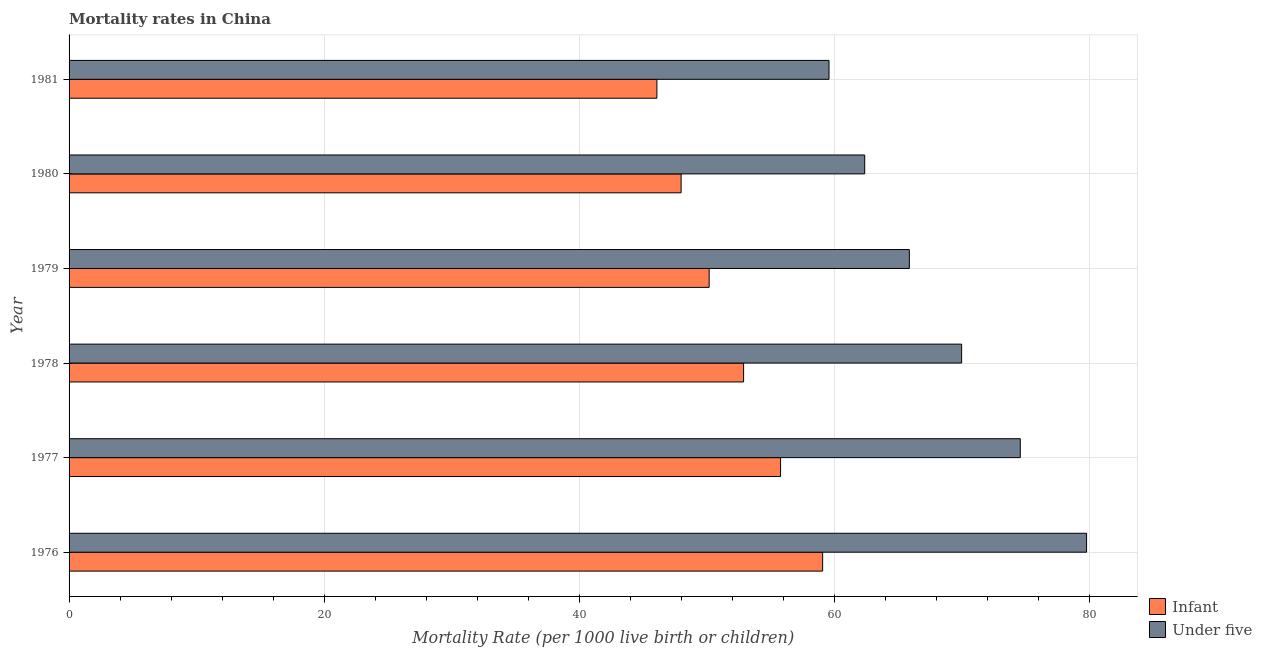Are the number of bars on each tick of the Y-axis equal?
Ensure brevity in your answer.  Yes. How many bars are there on the 4th tick from the top?
Offer a very short reply. 2. How many bars are there on the 3rd tick from the bottom?
Your answer should be very brief. 2. What is the label of the 4th group of bars from the top?
Your response must be concise. 1978. What is the under-5 mortality rate in 1979?
Offer a very short reply. 65.9. Across all years, what is the maximum infant mortality rate?
Offer a very short reply. 59.1. Across all years, what is the minimum under-5 mortality rate?
Give a very brief answer. 59.6. In which year was the infant mortality rate maximum?
Your response must be concise. 1976. What is the total infant mortality rate in the graph?
Your answer should be very brief. 312.1. What is the difference between the infant mortality rate in 1979 and that in 1980?
Make the answer very short. 2.2. What is the average under-5 mortality rate per year?
Ensure brevity in your answer.  68.72. In the year 1979, what is the difference between the infant mortality rate and under-5 mortality rate?
Your response must be concise. -15.7. What is the ratio of the under-5 mortality rate in 1980 to that in 1981?
Provide a succinct answer. 1.05. Is the difference between the under-5 mortality rate in 1979 and 1981 greater than the difference between the infant mortality rate in 1979 and 1981?
Ensure brevity in your answer.  Yes. What is the difference between the highest and the lowest under-5 mortality rate?
Provide a succinct answer. 20.2. In how many years, is the under-5 mortality rate greater than the average under-5 mortality rate taken over all years?
Provide a short and direct response. 3. Is the sum of the infant mortality rate in 1980 and 1981 greater than the maximum under-5 mortality rate across all years?
Offer a very short reply. Yes. What does the 2nd bar from the top in 1978 represents?
Ensure brevity in your answer.  Infant. What does the 1st bar from the bottom in 1981 represents?
Your response must be concise. Infant. Are all the bars in the graph horizontal?
Your response must be concise. Yes. Are the values on the major ticks of X-axis written in scientific E-notation?
Offer a very short reply. No. How many legend labels are there?
Give a very brief answer. 2. How are the legend labels stacked?
Ensure brevity in your answer.  Vertical. What is the title of the graph?
Your answer should be compact. Mortality rates in China. Does "RDB nonconcessional" appear as one of the legend labels in the graph?
Provide a succinct answer. No. What is the label or title of the X-axis?
Keep it short and to the point. Mortality Rate (per 1000 live birth or children). What is the label or title of the Y-axis?
Provide a short and direct response. Year. What is the Mortality Rate (per 1000 live birth or children) in Infant in 1976?
Provide a succinct answer. 59.1. What is the Mortality Rate (per 1000 live birth or children) in Under five in 1976?
Your response must be concise. 79.8. What is the Mortality Rate (per 1000 live birth or children) in Infant in 1977?
Your response must be concise. 55.8. What is the Mortality Rate (per 1000 live birth or children) of Under five in 1977?
Keep it short and to the point. 74.6. What is the Mortality Rate (per 1000 live birth or children) in Infant in 1978?
Give a very brief answer. 52.9. What is the Mortality Rate (per 1000 live birth or children) of Infant in 1979?
Your answer should be compact. 50.2. What is the Mortality Rate (per 1000 live birth or children) of Under five in 1979?
Ensure brevity in your answer.  65.9. What is the Mortality Rate (per 1000 live birth or children) of Infant in 1980?
Provide a short and direct response. 48. What is the Mortality Rate (per 1000 live birth or children) of Under five in 1980?
Your answer should be compact. 62.4. What is the Mortality Rate (per 1000 live birth or children) of Infant in 1981?
Give a very brief answer. 46.1. What is the Mortality Rate (per 1000 live birth or children) of Under five in 1981?
Your answer should be very brief. 59.6. Across all years, what is the maximum Mortality Rate (per 1000 live birth or children) in Infant?
Give a very brief answer. 59.1. Across all years, what is the maximum Mortality Rate (per 1000 live birth or children) in Under five?
Your response must be concise. 79.8. Across all years, what is the minimum Mortality Rate (per 1000 live birth or children) of Infant?
Offer a very short reply. 46.1. Across all years, what is the minimum Mortality Rate (per 1000 live birth or children) of Under five?
Provide a short and direct response. 59.6. What is the total Mortality Rate (per 1000 live birth or children) in Infant in the graph?
Give a very brief answer. 312.1. What is the total Mortality Rate (per 1000 live birth or children) in Under five in the graph?
Your answer should be very brief. 412.3. What is the difference between the Mortality Rate (per 1000 live birth or children) of Infant in 1976 and that in 1977?
Offer a very short reply. 3.3. What is the difference between the Mortality Rate (per 1000 live birth or children) of Infant in 1976 and that in 1978?
Provide a short and direct response. 6.2. What is the difference between the Mortality Rate (per 1000 live birth or children) of Under five in 1976 and that in 1978?
Ensure brevity in your answer.  9.8. What is the difference between the Mortality Rate (per 1000 live birth or children) of Infant in 1976 and that in 1979?
Offer a very short reply. 8.9. What is the difference between the Mortality Rate (per 1000 live birth or children) of Under five in 1976 and that in 1981?
Keep it short and to the point. 20.2. What is the difference between the Mortality Rate (per 1000 live birth or children) of Infant in 1977 and that in 1978?
Ensure brevity in your answer.  2.9. What is the difference between the Mortality Rate (per 1000 live birth or children) in Infant in 1977 and that in 1981?
Provide a succinct answer. 9.7. What is the difference between the Mortality Rate (per 1000 live birth or children) in Infant in 1978 and that in 1979?
Provide a succinct answer. 2.7. What is the difference between the Mortality Rate (per 1000 live birth or children) in Infant in 1978 and that in 1980?
Your answer should be compact. 4.9. What is the difference between the Mortality Rate (per 1000 live birth or children) in Infant in 1979 and that in 1981?
Give a very brief answer. 4.1. What is the difference between the Mortality Rate (per 1000 live birth or children) in Infant in 1976 and the Mortality Rate (per 1000 live birth or children) in Under five in 1977?
Keep it short and to the point. -15.5. What is the difference between the Mortality Rate (per 1000 live birth or children) of Infant in 1976 and the Mortality Rate (per 1000 live birth or children) of Under five in 1978?
Keep it short and to the point. -10.9. What is the difference between the Mortality Rate (per 1000 live birth or children) of Infant in 1976 and the Mortality Rate (per 1000 live birth or children) of Under five in 1979?
Ensure brevity in your answer.  -6.8. What is the difference between the Mortality Rate (per 1000 live birth or children) in Infant in 1976 and the Mortality Rate (per 1000 live birth or children) in Under five in 1981?
Keep it short and to the point. -0.5. What is the difference between the Mortality Rate (per 1000 live birth or children) of Infant in 1977 and the Mortality Rate (per 1000 live birth or children) of Under five in 1978?
Ensure brevity in your answer.  -14.2. What is the difference between the Mortality Rate (per 1000 live birth or children) in Infant in 1978 and the Mortality Rate (per 1000 live birth or children) in Under five in 1979?
Keep it short and to the point. -13. What is the difference between the Mortality Rate (per 1000 live birth or children) in Infant in 1978 and the Mortality Rate (per 1000 live birth or children) in Under five in 1980?
Your response must be concise. -9.5. What is the difference between the Mortality Rate (per 1000 live birth or children) in Infant in 1979 and the Mortality Rate (per 1000 live birth or children) in Under five in 1981?
Your response must be concise. -9.4. What is the difference between the Mortality Rate (per 1000 live birth or children) in Infant in 1980 and the Mortality Rate (per 1000 live birth or children) in Under five in 1981?
Keep it short and to the point. -11.6. What is the average Mortality Rate (per 1000 live birth or children) in Infant per year?
Make the answer very short. 52.02. What is the average Mortality Rate (per 1000 live birth or children) of Under five per year?
Keep it short and to the point. 68.72. In the year 1976, what is the difference between the Mortality Rate (per 1000 live birth or children) in Infant and Mortality Rate (per 1000 live birth or children) in Under five?
Your answer should be very brief. -20.7. In the year 1977, what is the difference between the Mortality Rate (per 1000 live birth or children) in Infant and Mortality Rate (per 1000 live birth or children) in Under five?
Your answer should be compact. -18.8. In the year 1978, what is the difference between the Mortality Rate (per 1000 live birth or children) in Infant and Mortality Rate (per 1000 live birth or children) in Under five?
Your response must be concise. -17.1. In the year 1979, what is the difference between the Mortality Rate (per 1000 live birth or children) of Infant and Mortality Rate (per 1000 live birth or children) of Under five?
Your answer should be compact. -15.7. In the year 1980, what is the difference between the Mortality Rate (per 1000 live birth or children) in Infant and Mortality Rate (per 1000 live birth or children) in Under five?
Your answer should be very brief. -14.4. In the year 1981, what is the difference between the Mortality Rate (per 1000 live birth or children) of Infant and Mortality Rate (per 1000 live birth or children) of Under five?
Give a very brief answer. -13.5. What is the ratio of the Mortality Rate (per 1000 live birth or children) in Infant in 1976 to that in 1977?
Give a very brief answer. 1.06. What is the ratio of the Mortality Rate (per 1000 live birth or children) of Under five in 1976 to that in 1977?
Give a very brief answer. 1.07. What is the ratio of the Mortality Rate (per 1000 live birth or children) in Infant in 1976 to that in 1978?
Your response must be concise. 1.12. What is the ratio of the Mortality Rate (per 1000 live birth or children) of Under five in 1976 to that in 1978?
Offer a very short reply. 1.14. What is the ratio of the Mortality Rate (per 1000 live birth or children) of Infant in 1976 to that in 1979?
Offer a terse response. 1.18. What is the ratio of the Mortality Rate (per 1000 live birth or children) in Under five in 1976 to that in 1979?
Offer a terse response. 1.21. What is the ratio of the Mortality Rate (per 1000 live birth or children) in Infant in 1976 to that in 1980?
Your response must be concise. 1.23. What is the ratio of the Mortality Rate (per 1000 live birth or children) of Under five in 1976 to that in 1980?
Your answer should be compact. 1.28. What is the ratio of the Mortality Rate (per 1000 live birth or children) of Infant in 1976 to that in 1981?
Your answer should be very brief. 1.28. What is the ratio of the Mortality Rate (per 1000 live birth or children) in Under five in 1976 to that in 1981?
Give a very brief answer. 1.34. What is the ratio of the Mortality Rate (per 1000 live birth or children) in Infant in 1977 to that in 1978?
Make the answer very short. 1.05. What is the ratio of the Mortality Rate (per 1000 live birth or children) of Under five in 1977 to that in 1978?
Your answer should be very brief. 1.07. What is the ratio of the Mortality Rate (per 1000 live birth or children) in Infant in 1977 to that in 1979?
Give a very brief answer. 1.11. What is the ratio of the Mortality Rate (per 1000 live birth or children) in Under five in 1977 to that in 1979?
Your response must be concise. 1.13. What is the ratio of the Mortality Rate (per 1000 live birth or children) in Infant in 1977 to that in 1980?
Give a very brief answer. 1.16. What is the ratio of the Mortality Rate (per 1000 live birth or children) in Under five in 1977 to that in 1980?
Your answer should be compact. 1.2. What is the ratio of the Mortality Rate (per 1000 live birth or children) in Infant in 1977 to that in 1981?
Offer a terse response. 1.21. What is the ratio of the Mortality Rate (per 1000 live birth or children) of Under five in 1977 to that in 1981?
Keep it short and to the point. 1.25. What is the ratio of the Mortality Rate (per 1000 live birth or children) of Infant in 1978 to that in 1979?
Keep it short and to the point. 1.05. What is the ratio of the Mortality Rate (per 1000 live birth or children) of Under five in 1978 to that in 1979?
Offer a very short reply. 1.06. What is the ratio of the Mortality Rate (per 1000 live birth or children) in Infant in 1978 to that in 1980?
Ensure brevity in your answer.  1.1. What is the ratio of the Mortality Rate (per 1000 live birth or children) of Under five in 1978 to that in 1980?
Provide a short and direct response. 1.12. What is the ratio of the Mortality Rate (per 1000 live birth or children) in Infant in 1978 to that in 1981?
Offer a very short reply. 1.15. What is the ratio of the Mortality Rate (per 1000 live birth or children) in Under five in 1978 to that in 1981?
Your answer should be compact. 1.17. What is the ratio of the Mortality Rate (per 1000 live birth or children) of Infant in 1979 to that in 1980?
Offer a terse response. 1.05. What is the ratio of the Mortality Rate (per 1000 live birth or children) in Under five in 1979 to that in 1980?
Ensure brevity in your answer.  1.06. What is the ratio of the Mortality Rate (per 1000 live birth or children) in Infant in 1979 to that in 1981?
Provide a succinct answer. 1.09. What is the ratio of the Mortality Rate (per 1000 live birth or children) of Under five in 1979 to that in 1981?
Provide a short and direct response. 1.11. What is the ratio of the Mortality Rate (per 1000 live birth or children) in Infant in 1980 to that in 1981?
Your answer should be very brief. 1.04. What is the ratio of the Mortality Rate (per 1000 live birth or children) of Under five in 1980 to that in 1981?
Provide a short and direct response. 1.05. What is the difference between the highest and the second highest Mortality Rate (per 1000 live birth or children) of Infant?
Your answer should be very brief. 3.3. What is the difference between the highest and the lowest Mortality Rate (per 1000 live birth or children) of Infant?
Your answer should be very brief. 13. What is the difference between the highest and the lowest Mortality Rate (per 1000 live birth or children) of Under five?
Ensure brevity in your answer.  20.2. 